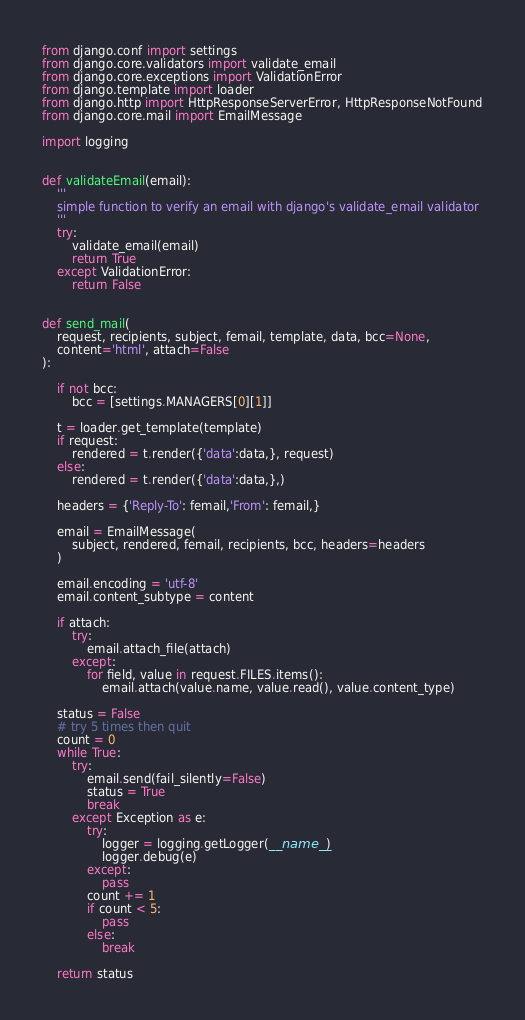<code> <loc_0><loc_0><loc_500><loc_500><_Python_>from django.conf import settings
from django.core.validators import validate_email
from django.core.exceptions import ValidationError
from django.template import loader
from django.http import HttpResponseServerError, HttpResponseNotFound
from django.core.mail import EmailMessage

import logging


def validateEmail(email):
    '''
    simple function to verify an email with django's validate_email validator
    '''
    try:
        validate_email(email)
        return True
    except ValidationError:
        return False


def send_mail(
    request, recipients, subject, femail, template, data, bcc=None,
    content='html', attach=False
):

    if not bcc:
        bcc = [settings.MANAGERS[0][1]]

    t = loader.get_template(template)
    if request:
        rendered = t.render({'data':data,}, request)
    else:
        rendered = t.render({'data':data,},)

    headers = {'Reply-To': femail,'From': femail,}

    email = EmailMessage(
        subject, rendered, femail, recipients, bcc, headers=headers
    )

    email.encoding = 'utf-8'
    email.content_subtype = content

    if attach:
        try:
            email.attach_file(attach)
        except:
            for field, value in request.FILES.items():
                email.attach(value.name, value.read(), value.content_type)

    status = False
    # try 5 times then quit
    count = 0
    while True:
        try:
            email.send(fail_silently=False)
            status = True
            break
        except Exception as e:
            try:
                logger = logging.getLogger(__name__)
                logger.debug(e)
            except:
                pass
            count += 1
            if count < 5:
                pass
            else:
                break

    return status
</code> 